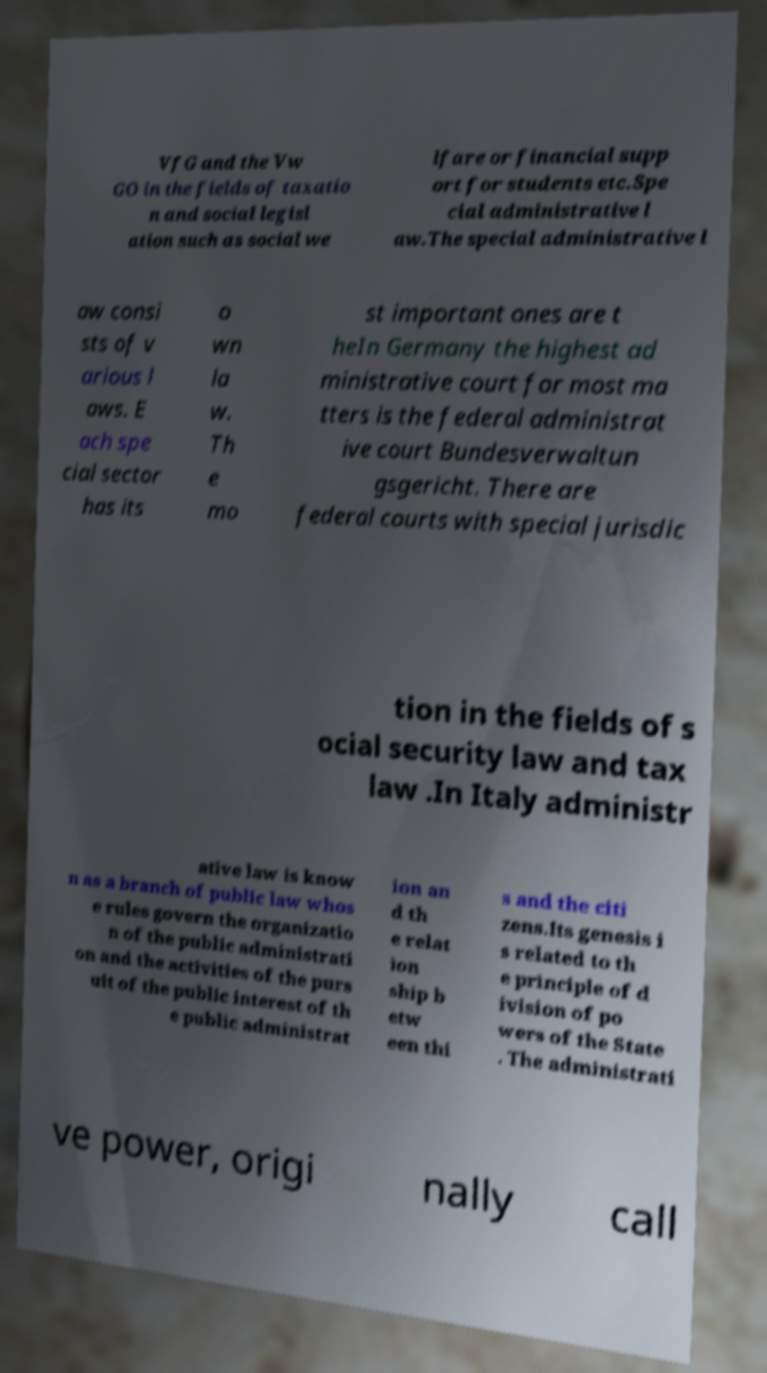I need the written content from this picture converted into text. Can you do that? VfG and the Vw GO in the fields of taxatio n and social legisl ation such as social we lfare or financial supp ort for students etc.Spe cial administrative l aw.The special administrative l aw consi sts of v arious l aws. E ach spe cial sector has its o wn la w. Th e mo st important ones are t heIn Germany the highest ad ministrative court for most ma tters is the federal administrat ive court Bundesverwaltun gsgericht. There are federal courts with special jurisdic tion in the fields of s ocial security law and tax law .In Italy administr ative law is know n as a branch of public law whos e rules govern the organizatio n of the public administrati on and the activities of the purs uit of the public interest of th e public administrat ion an d th e relat ion ship b etw een thi s and the citi zens.Its genesis i s related to th e principle of d ivision of po wers of the State . The administrati ve power, origi nally call 